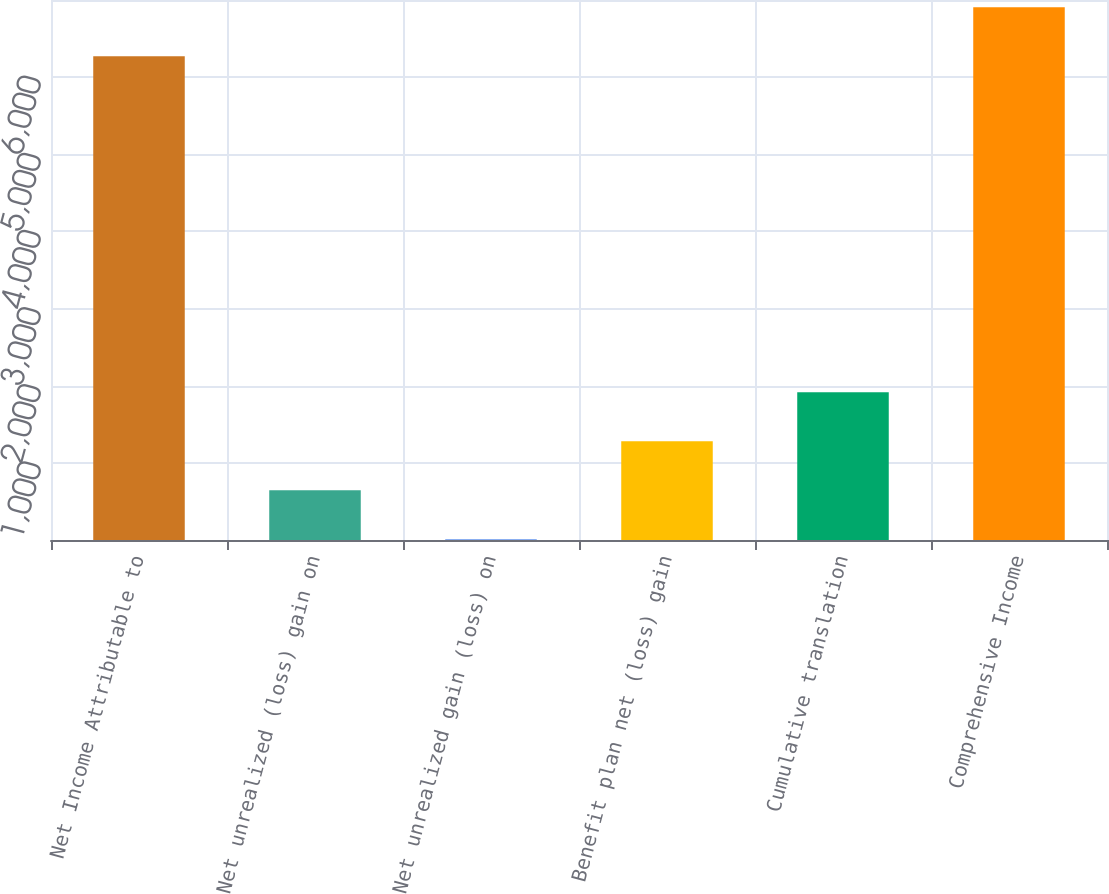<chart> <loc_0><loc_0><loc_500><loc_500><bar_chart><fcel>Net Income Attributable to<fcel>Net unrealized (loss) gain on<fcel>Net unrealized gain (loss) on<fcel>Benefit plan net (loss) gain<fcel>Cumulative translation<fcel>Comprehensive Income<nl><fcel>6272<fcel>644.6<fcel>10<fcel>1279.2<fcel>1913.8<fcel>6906.6<nl></chart> 